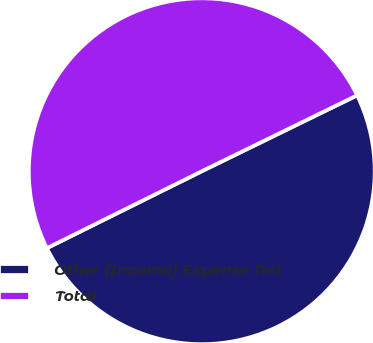Convert chart to OTSL. <chart><loc_0><loc_0><loc_500><loc_500><pie_chart><fcel>Other (Income) Expense Net<fcel>Total<nl><fcel>49.9%<fcel>50.1%<nl></chart> 